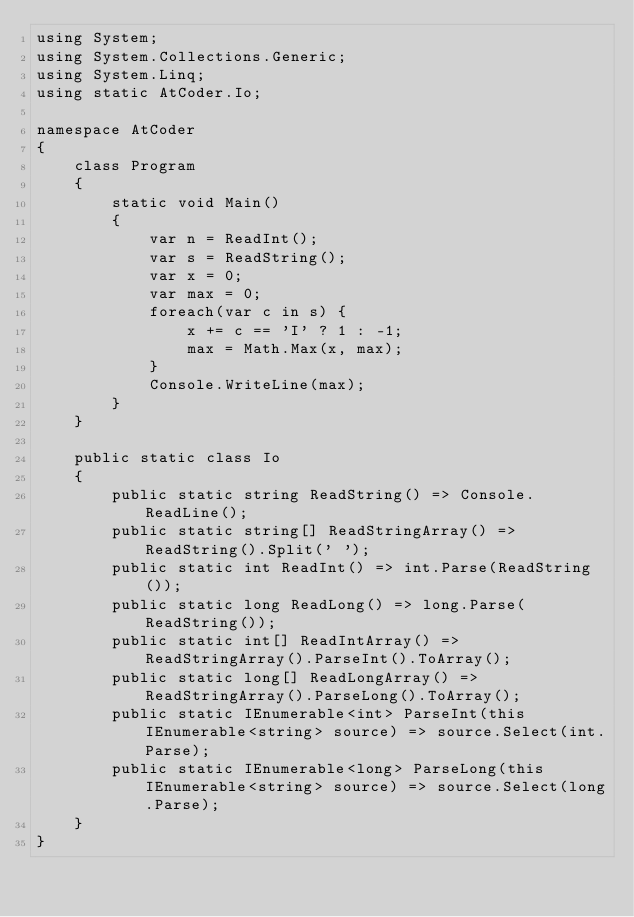<code> <loc_0><loc_0><loc_500><loc_500><_C#_>using System;
using System.Collections.Generic;
using System.Linq;
using static AtCoder.Io;

namespace AtCoder
{
    class Program
    {
        static void Main()
        {
            var n = ReadInt();
            var s = ReadString();
            var x = 0;
            var max = 0;
            foreach(var c in s) {
                x += c == 'I' ? 1 : -1;
                max = Math.Max(x, max);
            }
            Console.WriteLine(max);
        }
    }

    public static class Io
    {
        public static string ReadString() => Console.ReadLine();
        public static string[] ReadStringArray() => ReadString().Split(' ');
        public static int ReadInt() => int.Parse(ReadString());
        public static long ReadLong() => long.Parse(ReadString());
        public static int[] ReadIntArray() => ReadStringArray().ParseInt().ToArray();
        public static long[] ReadLongArray() => ReadStringArray().ParseLong().ToArray();
        public static IEnumerable<int> ParseInt(this IEnumerable<string> source) => source.Select(int.Parse);
        public static IEnumerable<long> ParseLong(this IEnumerable<string> source) => source.Select(long.Parse);
    }
}
</code> 